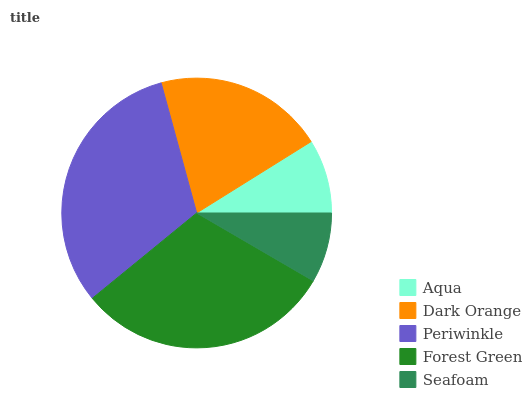Is Seafoam the minimum?
Answer yes or no. Yes. Is Periwinkle the maximum?
Answer yes or no. Yes. Is Dark Orange the minimum?
Answer yes or no. No. Is Dark Orange the maximum?
Answer yes or no. No. Is Dark Orange greater than Aqua?
Answer yes or no. Yes. Is Aqua less than Dark Orange?
Answer yes or no. Yes. Is Aqua greater than Dark Orange?
Answer yes or no. No. Is Dark Orange less than Aqua?
Answer yes or no. No. Is Dark Orange the high median?
Answer yes or no. Yes. Is Dark Orange the low median?
Answer yes or no. Yes. Is Aqua the high median?
Answer yes or no. No. Is Seafoam the low median?
Answer yes or no. No. 